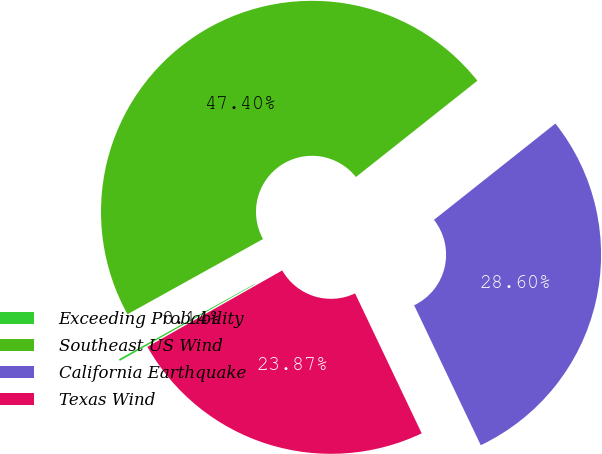Convert chart to OTSL. <chart><loc_0><loc_0><loc_500><loc_500><pie_chart><fcel>Exceeding Probability<fcel>Southeast US Wind<fcel>California Earthquake<fcel>Texas Wind<nl><fcel>0.14%<fcel>47.4%<fcel>28.6%<fcel>23.87%<nl></chart> 